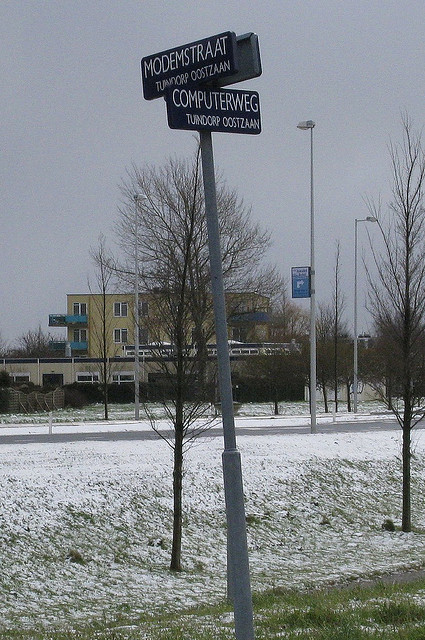<image>What city is this? I don't know what city this is. It could be 'new port richey', 'springfield', 'omaha', 'tuindorp oostzaan', 'kansas city', 'denver', or 'aurora'. What city is this? I don't know what city this is. It could be any of the mentioned cities. 